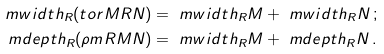Convert formula to latex. <formula><loc_0><loc_0><loc_500><loc_500>\ m w i d t h _ { R } ( \L t o r M R N ) & = \ m w i d t h _ { R } M + \ m w i d t h _ { R } N \, ; \\ \ m d e p t h _ { R } ( \rho m R M N ) & = \ m w i d t h _ { R } M + \ m d e p t h _ { R } N \, .</formula> 